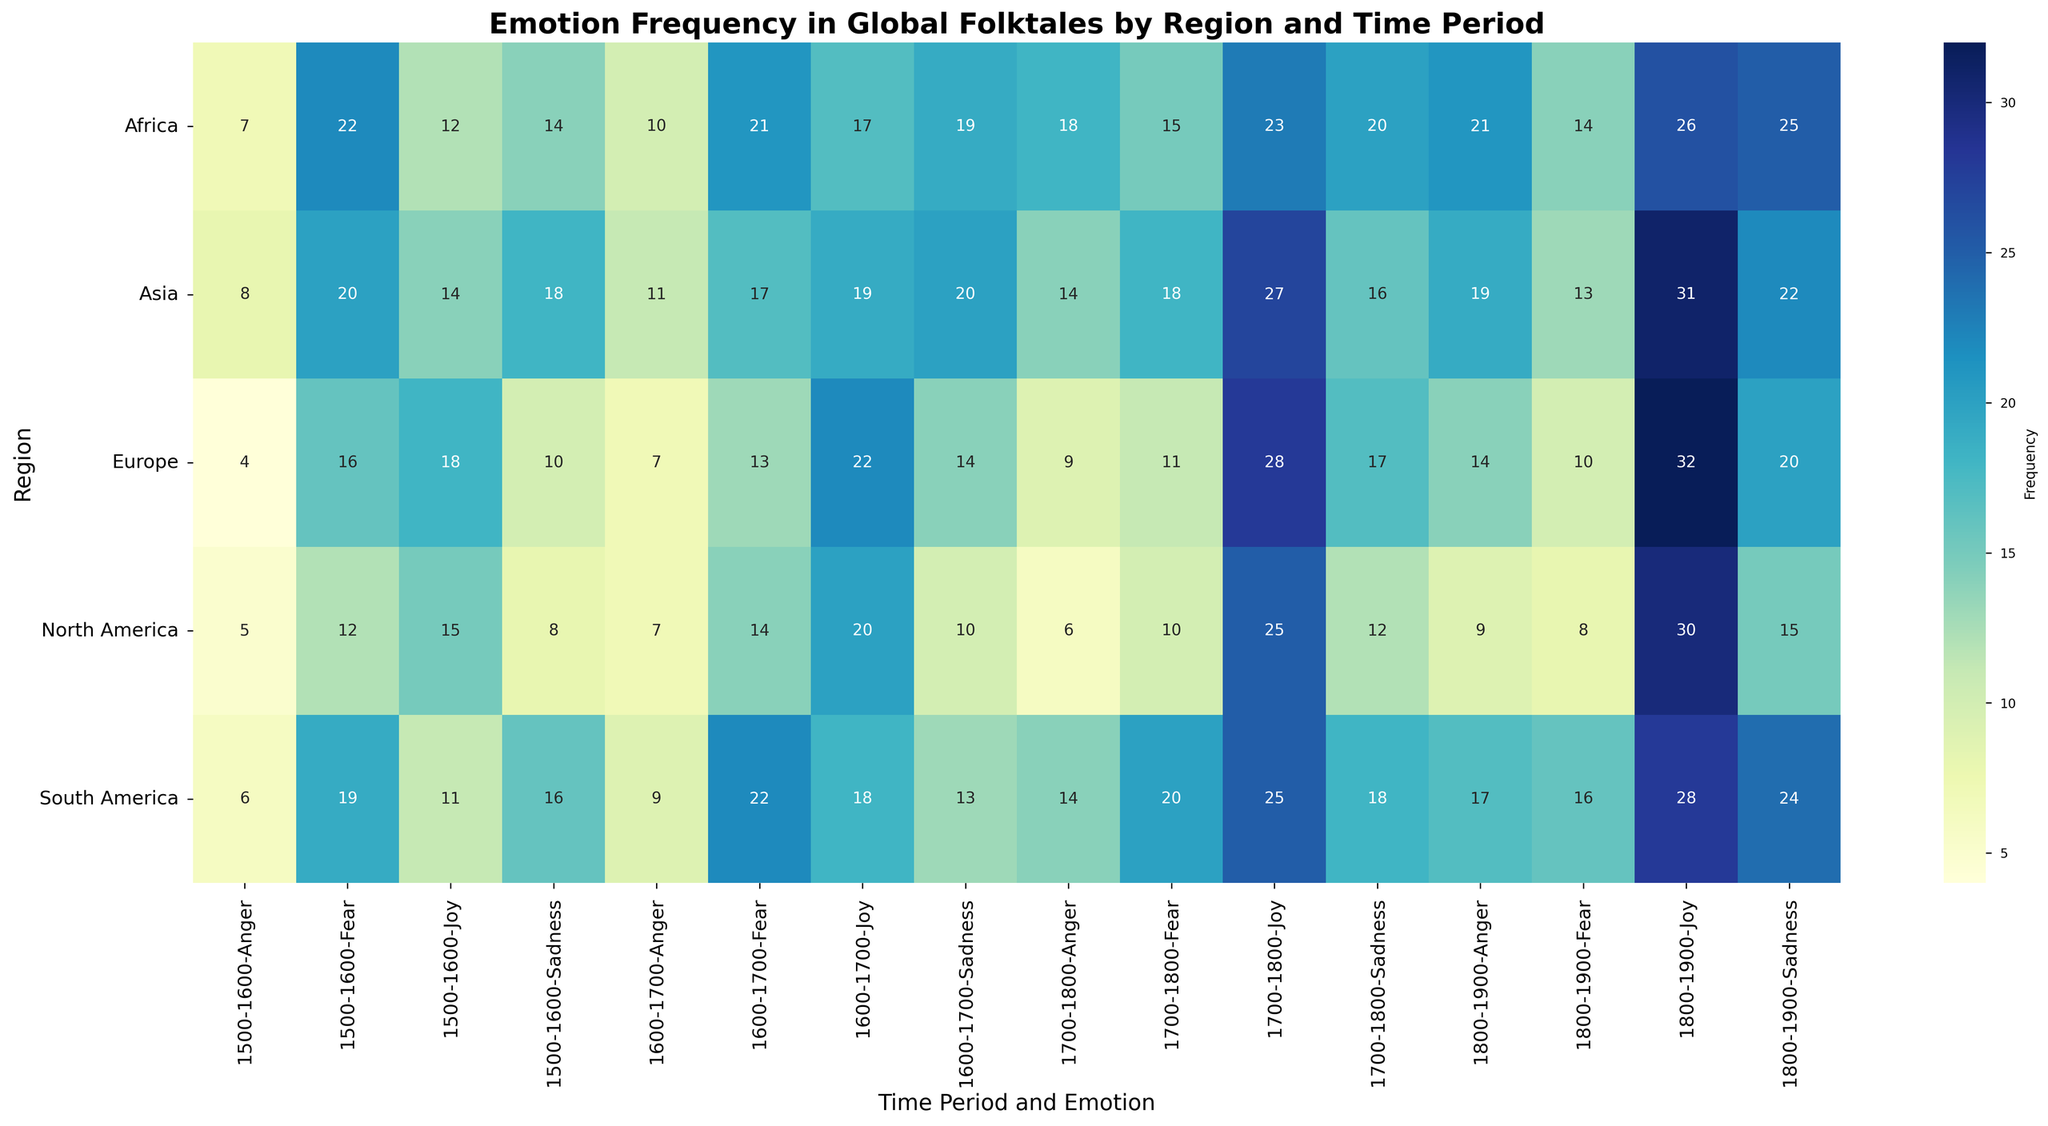What's the highest frequency of 'Joy' in North America across all time periods? To find this, look at the row for North America under the 'Joy' columns for each time period. The frequencies are 15, 20, 25, and 30. The highest among these is 30.
Answer: 30 Which region had the highest frequency of 'Fear' in the 1600-1700 period? Look at the '1600-1700' columns under 'Fear' for all regions. The frequencies are 14 (North America), 13 (Europe), 17 (Asia), 21 (Africa), and 22 (South America). The highest value is 22 in South America.
Answer: South America How does the frequency of 'Sadness' in Asia in the 1700-1800 period compare to that in Europe for the same period? Look at the '1700-1800' columns under 'Sadness' for Asia and Europe. The frequencies are 16 (Asia) and 17 (Europe). 16 is less than 17.
Answer: Less What is the total frequency of 'Anger' in Africa across all time periods? Add up the 'Anger' frequencies for Africa: 7 (1500-1600), 10 (1600-1700), 18 (1700-1800), and 21 (1800-1900). The total is 7 + 10 + 18 + 21 = 56.
Answer: 56 Which time period saw the lowest frequency of 'Joy' in South America? Look at the 'Joy' columns across all time periods for South America. The frequencies are 11, 18, 25, and 28. The lowest value is 11 in the 1500-1600 period.
Answer: 1500-1600 Among all regions and time periods, where is the frequency of 'Fear' the highest? Compare the highest 'Fear' values across all regions and time periods: North America (1500-1600, 12), Europe (1500-1600, 16), Asia (1500-1600, 20), Africa (1500-1600, 22), and South America (1600-1700, 22). The highest are 22 in Africa (1500-1600) and 22 in South America (1600-1700).
Answer: Africa (1500-1600) and South America (1600-1700) Is the frequency of 'Sadness' generally increasing or decreasing over time in Europe? Look at the 'Sadness' columns over time for Europe. The frequencies are 10 (1500-1600), 14 (1600-1700), 17 (1700-1800), and 20 (1800-1900). The trend is increasing.
Answer: Increasing 